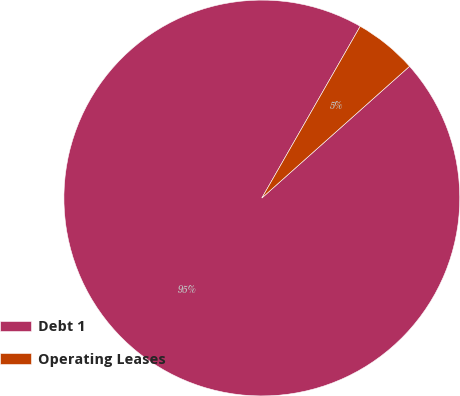Convert chart. <chart><loc_0><loc_0><loc_500><loc_500><pie_chart><fcel>Debt 1<fcel>Operating Leases<nl><fcel>94.87%<fcel>5.13%<nl></chart> 